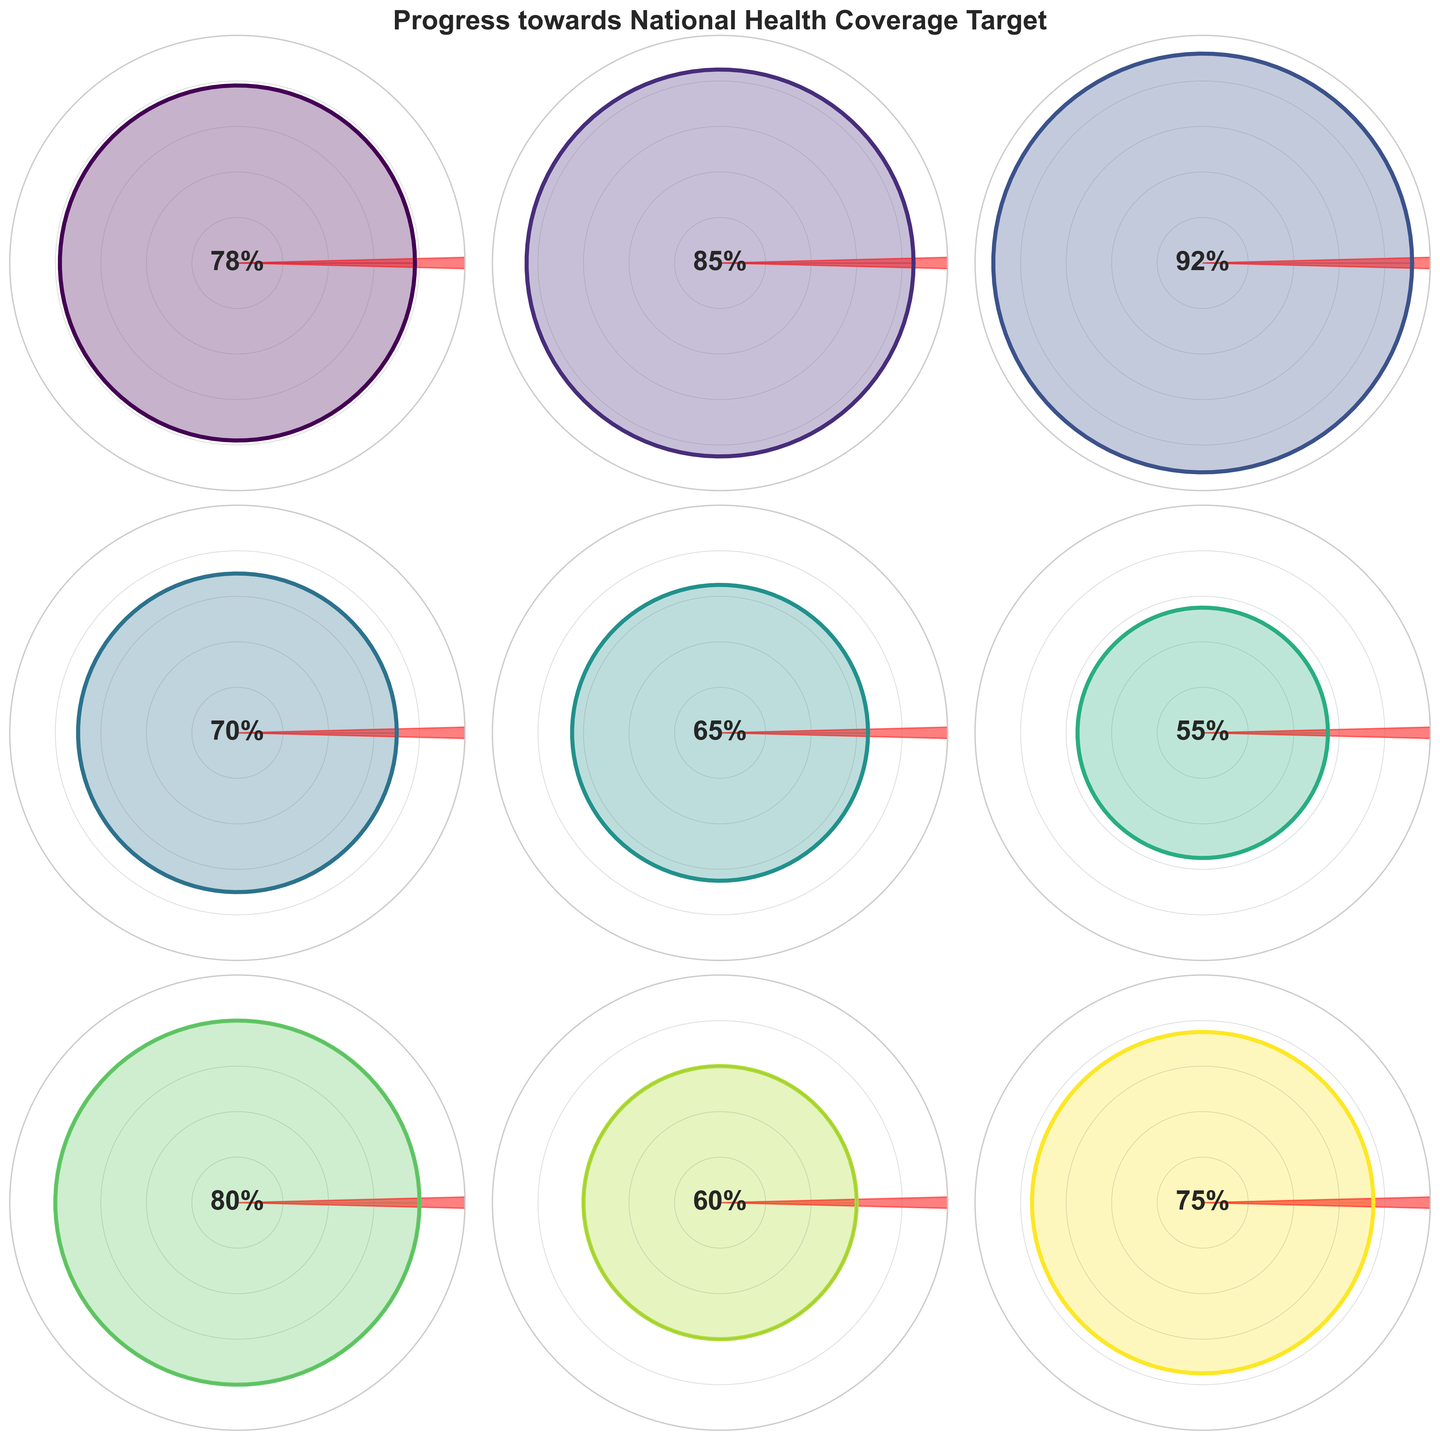What is the title of the figure? The title of the figure appears at the top and reads 'Progress towards National Health Coverage Target'.
Answer: 'Progress towards National Health Coverage Target' How many different service types are depicted in the figure? There are 9 subplots representing different service types (Primary Care, Maternal Health, Immunization, Infectious Disease Control, Non-Communicable Diseases, Mental Health, Emergency Services, Specialist Care, Pharmaceutical Access).
Answer: 9 Which service type has the highest coverage percentage? Looking at the center label of each gauge chart, Immunization has the highest coverage percentage with 92%.
Answer: Immunization Which service type has the lowest coverage percentage? The gauge chart for Mental Health shows the lowest coverage percentage, which is 55%.
Answer: Mental Health What is the average coverage percentage across all service types? Add the coverage percentages (78 + 85 + 92 + 70 + 65 + 55 + 80 + 60 + 75) to get 660. Then divide this sum by the number of service types, which is 9. The average coverage percentage is 660/9 ≈ 73.33%.
Answer: 73.33% What is the range of coverage percentages among the service types? The range is calculated by subtracting the smallest percentage from the largest percentage. The largest percentage is 92% (Immunization), and the smallest percentage is 55% (Mental Health). So, 92 - 55 = 37%.
Answer: 37% Which service type is closest to meeting its target? Immunization, with 92%, is closest to the 100% target.
Answer: Immunization How many service types have a coverage percentage above 75%? The service types with coverage percentages above 75% are Primary Care (78%), Maternal Health (85%), Immunization (92%), Emergency Services (80%). Thus, there are 4 service types above 75%.
Answer: 4 Which service has a gauge showing an arrow closest to its plotted value? The gauge nearest to its plotted value would be the one where the arrow length (representing the target, 100%) is the least different from the angle covered. Immunization, with 92%, is closest to its target.
Answer: Immunization What is the median coverage percentage across the depicted service types? Arrange the coverage percentages in ascending order: 55, 60, 65, 70, 75, 78, 80, 85, 92. The median is the middle value in this list, which is 75%.
Answer: 75% 